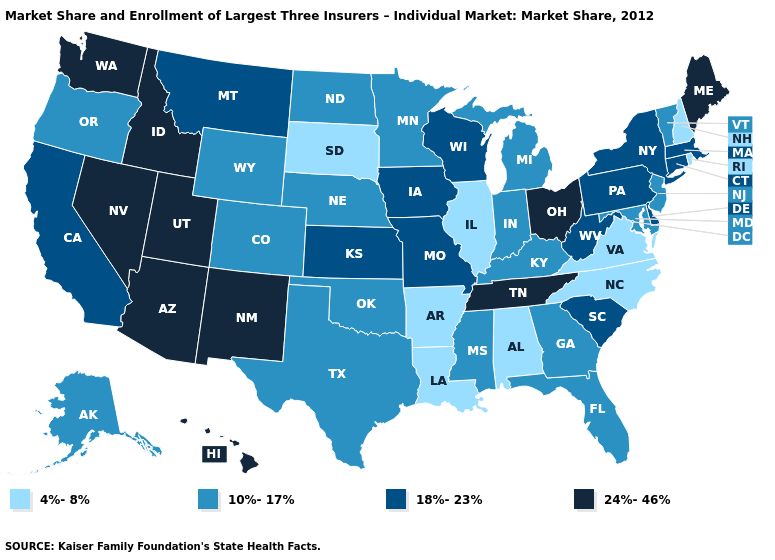Which states hav the highest value in the Northeast?
Short answer required. Maine. What is the highest value in the Northeast ?
Concise answer only. 24%-46%. Does Utah have a higher value than Idaho?
Be succinct. No. Does the map have missing data?
Be succinct. No. Does Ohio have the highest value in the MidWest?
Quick response, please. Yes. Which states hav the highest value in the MidWest?
Give a very brief answer. Ohio. Does Utah have the highest value in the West?
Keep it brief. Yes. Name the states that have a value in the range 18%-23%?
Concise answer only. California, Connecticut, Delaware, Iowa, Kansas, Massachusetts, Missouri, Montana, New York, Pennsylvania, South Carolina, West Virginia, Wisconsin. Among the states that border Wyoming , does South Dakota have the lowest value?
Answer briefly. Yes. What is the lowest value in states that border Michigan?
Answer briefly. 10%-17%. What is the highest value in states that border South Dakota?
Be succinct. 18%-23%. Name the states that have a value in the range 10%-17%?
Answer briefly. Alaska, Colorado, Florida, Georgia, Indiana, Kentucky, Maryland, Michigan, Minnesota, Mississippi, Nebraska, New Jersey, North Dakota, Oklahoma, Oregon, Texas, Vermont, Wyoming. Name the states that have a value in the range 10%-17%?
Give a very brief answer. Alaska, Colorado, Florida, Georgia, Indiana, Kentucky, Maryland, Michigan, Minnesota, Mississippi, Nebraska, New Jersey, North Dakota, Oklahoma, Oregon, Texas, Vermont, Wyoming. What is the highest value in the USA?
Be succinct. 24%-46%. Name the states that have a value in the range 10%-17%?
Short answer required. Alaska, Colorado, Florida, Georgia, Indiana, Kentucky, Maryland, Michigan, Minnesota, Mississippi, Nebraska, New Jersey, North Dakota, Oklahoma, Oregon, Texas, Vermont, Wyoming. 